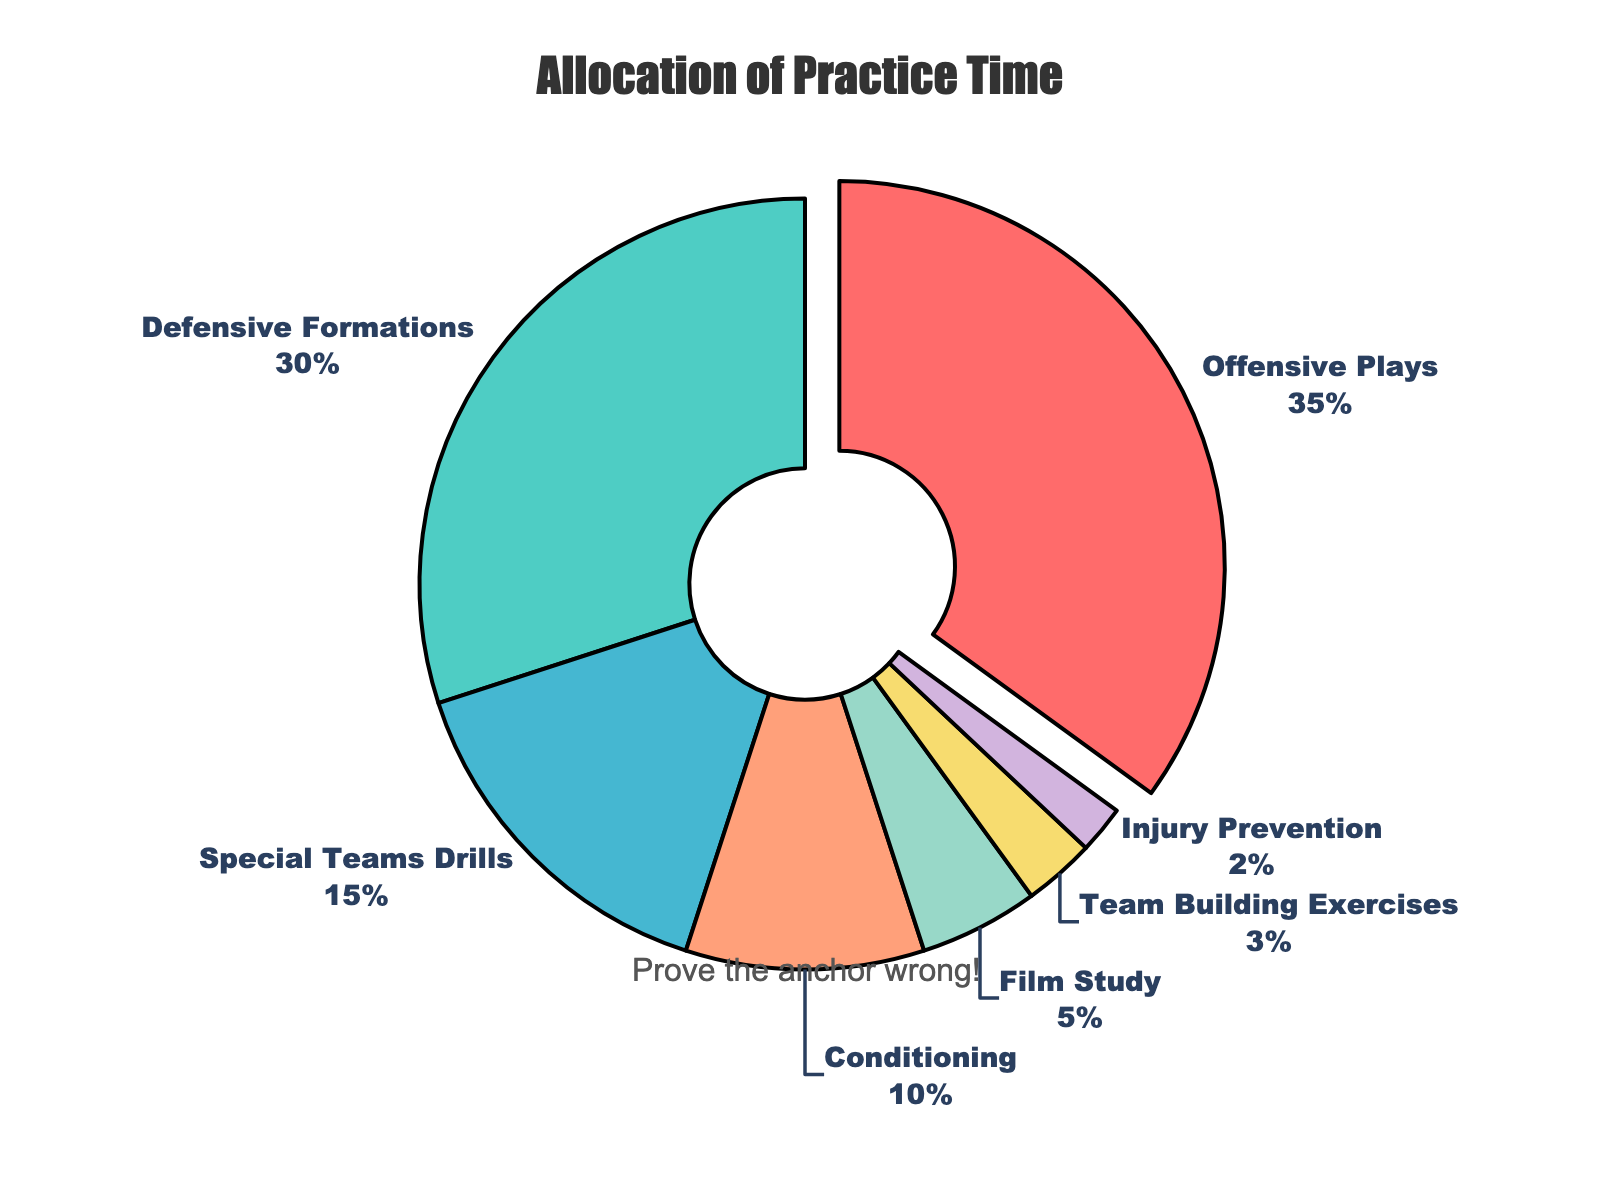What percentage of practice time is allocated to Offensive Plays? Locate the segment labeled "Offensive Plays" and read the percentage indicated.
Answer: 35% Which skill area receives the least practice time? Identify the segment with the smallest percentage, labeled as "Injury Prevention".
Answer: Injury Prevention What is the combined practice time allocated to Film Study and Team Building Exercises? Locate the percentages for Film Study and Team Building Exercises and add them together (5% + 3% = 8%).
Answer: 8% Which skill area gets more practice time: Conditioning or Special Teams Drills? Compare the percentages of Conditioning (10%) and Special Teams Drills (15%) and determine which is higher.
Answer: Special Teams Drills What is the ratio of practice time allocated to Defensive Formations compared to Film Study? Divide the percentage for Defensive Formations (30%) by the percentage for Film Study (5%).
Answer: 6:1 What visual attribute highlights the skill area with the highest percentage? Look for any visual distinction, such as a segment being slightly pulled out from the pie chart. The "Offensive Plays" segment is pulled out.
Answer: Segment is pulled out How much more practice time is allocated to Offensive Plays compared to Injury Prevention? Subtract the percentage of Injury Prevention (2%) from the percentage of Offensive Plays (35%) (35% - 2% = 33%).
Answer: 33% Which skill areas together make up more than half of the practice time? Add the percentages of the top skill areas until the sum exceeds 50%. Offensive Plays (35%) + Defensive Formations (30%) = 65%.
Answer: Offensive Plays and Defensive Formations If Team Building Exercises' practice time were increased by 2%, how would its new percentage compare to Conditioning's practice time? Add 2% to the existing percentage of Team Building Exercises (3% + 2% = 5%) and compare the result to Conditioning's 10%. 5% is less than 10%.
Answer: Less than Which color represents the segment for Special Teams Drills in the pie chart? Identify the color associated with the segment labeled "Special Teams Drills". It is the fourth segment, which is in salmon color.
Answer: Salmon 